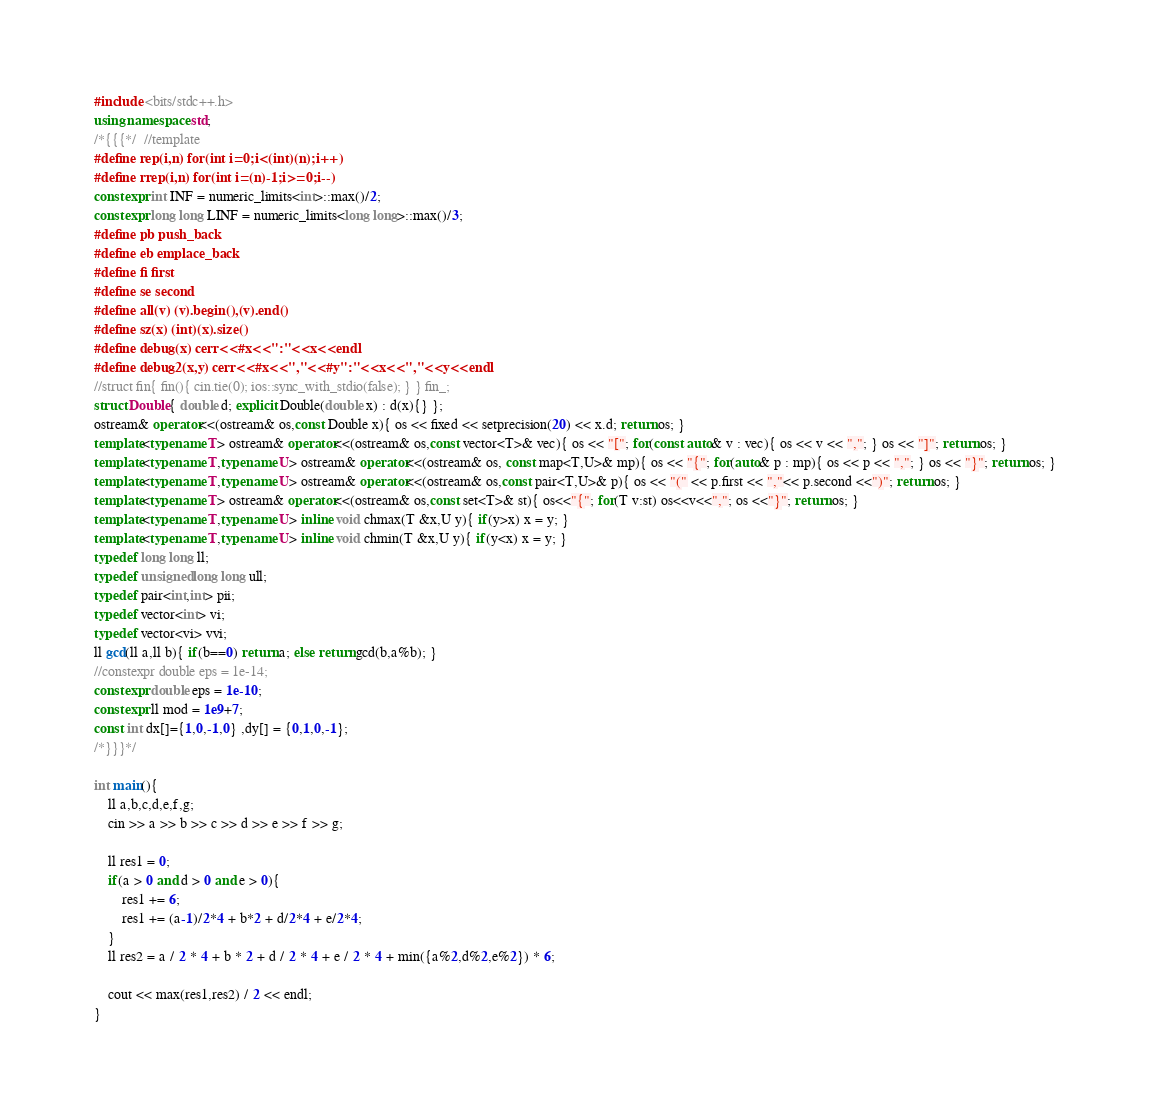<code> <loc_0><loc_0><loc_500><loc_500><_C++_>#include <bits/stdc++.h>
using namespace std;
/*{{{*/  //template
#define rep(i,n) for(int i=0;i<(int)(n);i++)
#define rrep(i,n) for(int i=(n)-1;i>=0;i--)
constexpr int INF = numeric_limits<int>::max()/2;
constexpr long long LINF = numeric_limits<long long>::max()/3;
#define pb push_back
#define eb emplace_back
#define fi first
#define se second
#define all(v) (v).begin(),(v).end()
#define sz(x) (int)(x).size()
#define debug(x) cerr<<#x<<":"<<x<<endl
#define debug2(x,y) cerr<<#x<<","<<#y":"<<x<<","<<y<<endl
//struct fin{ fin(){ cin.tie(0); ios::sync_with_stdio(false); } } fin_;
struct Double{ double d; explicit Double(double x) : d(x){} };
ostream& operator<<(ostream& os,const Double x){ os << fixed << setprecision(20) << x.d; return os; }
template<typename T> ostream& operator<<(ostream& os,const vector<T>& vec){ os << "["; for(const auto& v : vec){ os << v << ","; } os << "]"; return os; }
template<typename T,typename U> ostream& operator<<(ostream& os, const map<T,U>& mp){ os << "{"; for(auto& p : mp){ os << p << ","; } os << "}"; return os; }
template<typename T,typename U> ostream& operator<<(ostream& os,const pair<T,U>& p){ os << "(" << p.first << ","<< p.second <<")"; return os; }
template<typename T> ostream& operator<<(ostream& os,const set<T>& st){ os<<"{"; for(T v:st) os<<v<<","; os <<"}"; return os; }
template<typename T,typename U> inline void chmax(T &x,U y){ if(y>x) x = y; }
template<typename T,typename U> inline void chmin(T &x,U y){ if(y<x) x = y; }
typedef long long ll;
typedef unsigned long long ull;
typedef pair<int,int> pii;
typedef vector<int> vi;
typedef vector<vi> vvi;
ll gcd(ll a,ll b){ if(b==0) return a; else return gcd(b,a%b); }
//constexpr double eps = 1e-14; 
constexpr double eps = 1e-10; 
constexpr ll mod = 1e9+7;
const int dx[]={1,0,-1,0} ,dy[] = {0,1,0,-1};
/*}}}*/

int main(){
    ll a,b,c,d,e,f,g;
    cin >> a >> b >> c >> d >> e >> f >> g;

    ll res1 = 0;
    if(a > 0 and d > 0 and e > 0){
        res1 += 6;
        res1 += (a-1)/2*4 + b*2 + d/2*4 + e/2*4;
    }
    ll res2 = a / 2 * 4 + b * 2 + d / 2 * 4 + e / 2 * 4 + min({a%2,d%2,e%2}) * 6;

    cout << max(res1,res2) / 2 << endl;
}
</code> 